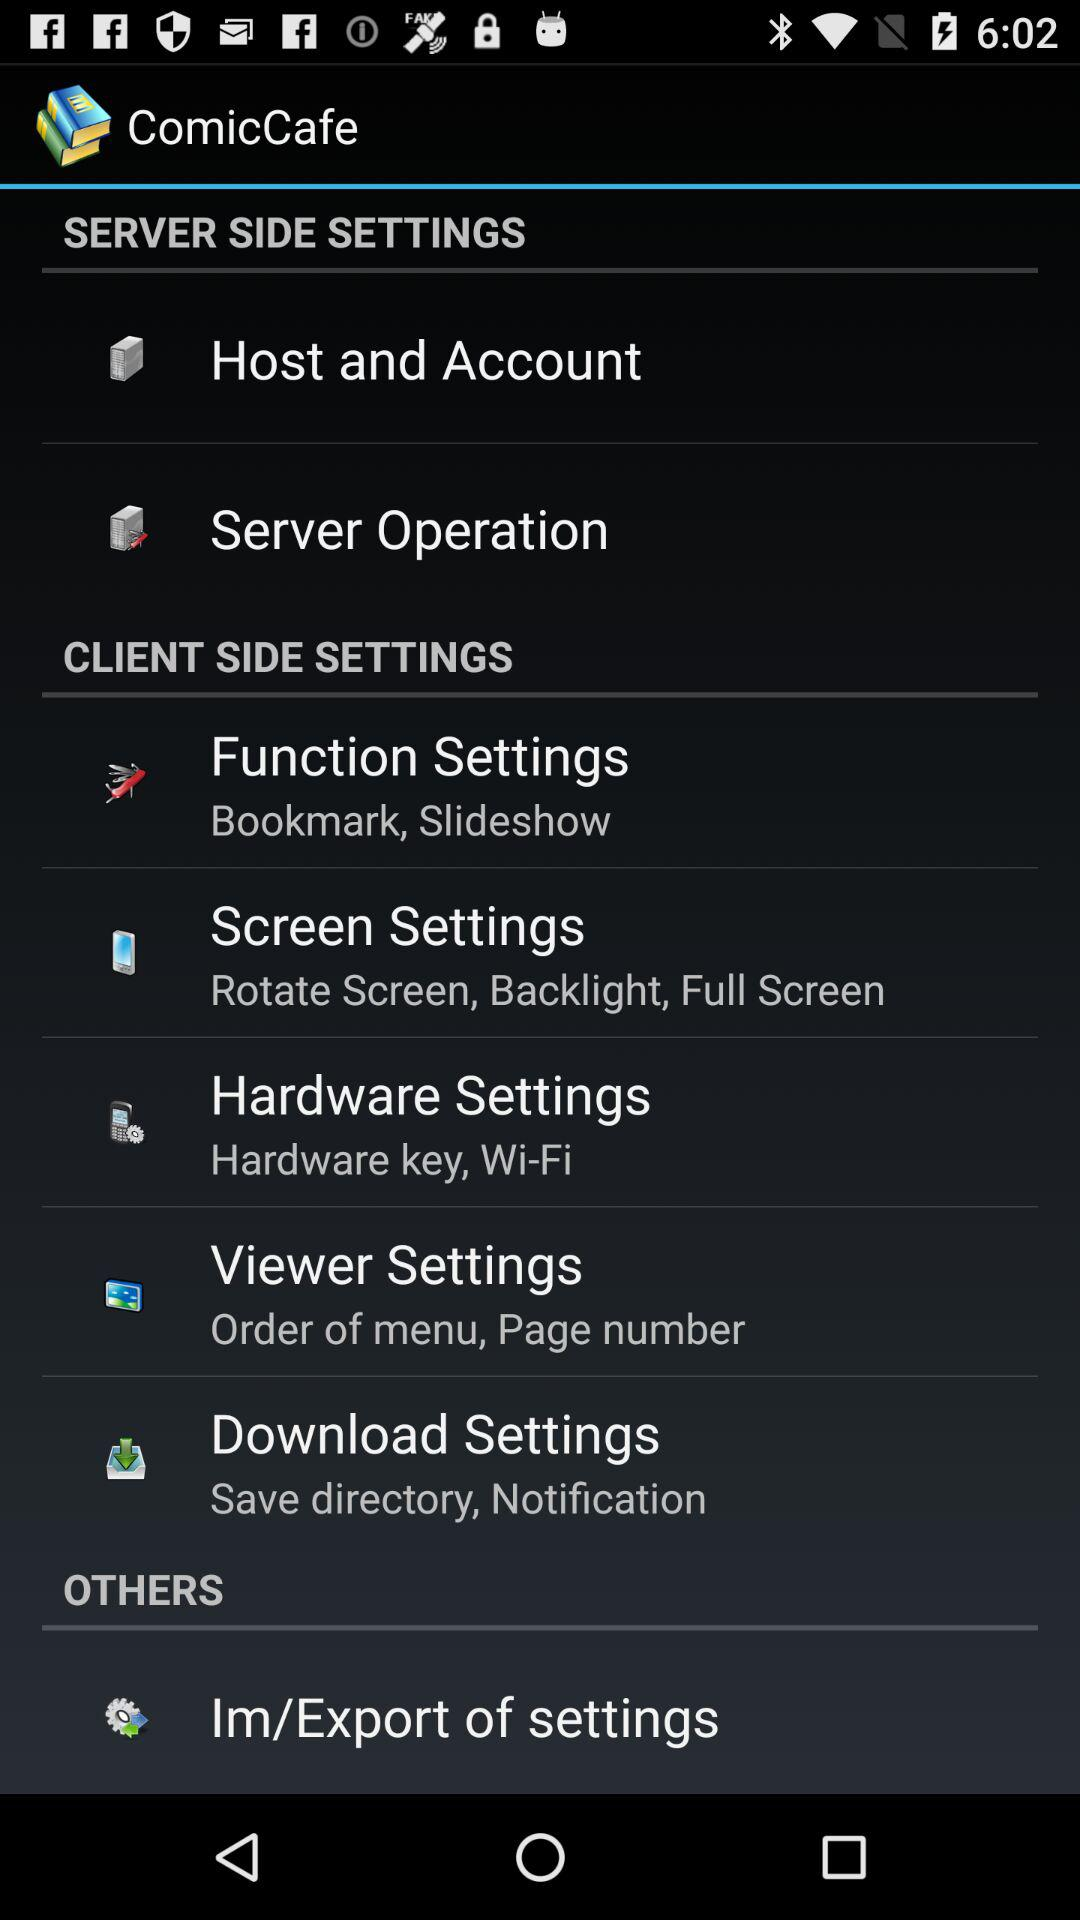What are the options under " Screen Settings"? The options are "Rotate Screen", "Backlight" and "Full Screen". 